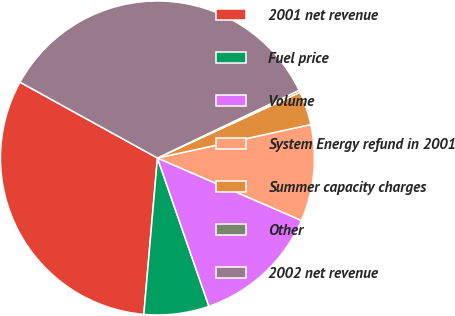<chart> <loc_0><loc_0><loc_500><loc_500><pie_chart><fcel>2001 net revenue<fcel>Fuel price<fcel>Volume<fcel>System Energy refund in 2001<fcel>Summer capacity charges<fcel>Other<fcel>2002 net revenue<nl><fcel>31.64%<fcel>6.7%<fcel>13.17%<fcel>9.93%<fcel>3.46%<fcel>0.22%<fcel>34.88%<nl></chart> 